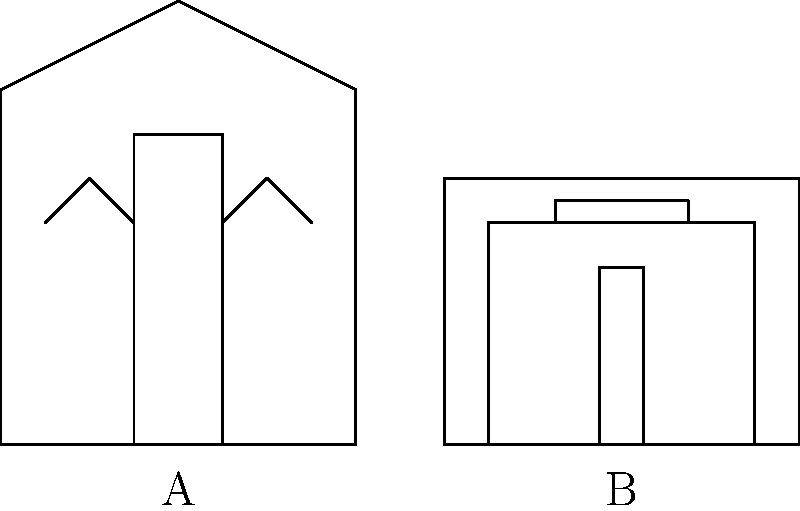Based on the architectural styles depicted in the image, which historical period is represented by building A, and which period is represented by building B? To answer this question, we need to analyze the architectural features of both buildings:

1. Building A:
   - Tall, vertical structure
   - Pointed arches
   - Large, ornate window (likely a rose window)
   - Spires or towers
   These features are characteristic of Gothic architecture, which flourished in Europe from the 12th to the 16th centuries.

2. Building B:
   - Horizontal emphasis
   - Symmetrical design
   - Ornate decorations (suggested by the detailed façade)
   - Grand entrance
   These features are typical of Baroque architecture, which was prevalent from the late 16th to the 18th centuries.

The Gothic style (Building A) preceded the Baroque style (Building B) in architectural history.
Answer: A: Gothic (12th-16th centuries), B: Baroque (late 16th-18th centuries) 